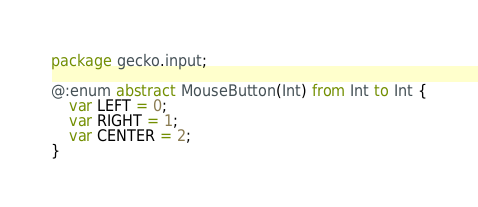Convert code to text. <code><loc_0><loc_0><loc_500><loc_500><_Haxe_>package gecko.input;

@:enum abstract MouseButton(Int) from Int to Int {
    var LEFT = 0;
    var RIGHT = 1;
    var CENTER = 2;
}</code> 